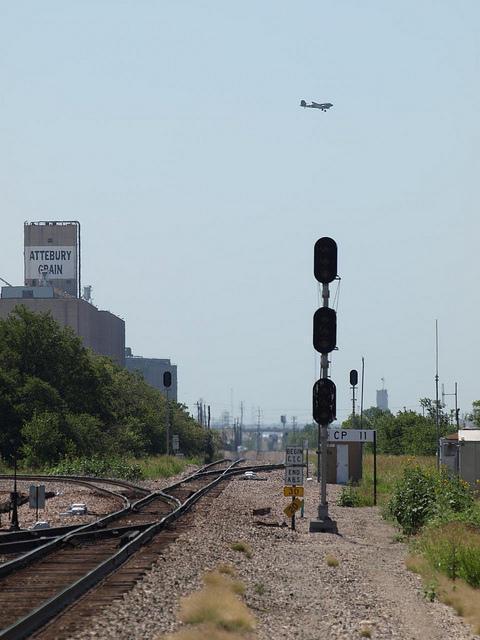How many rail tracks are there?
Give a very brief answer. 3. 